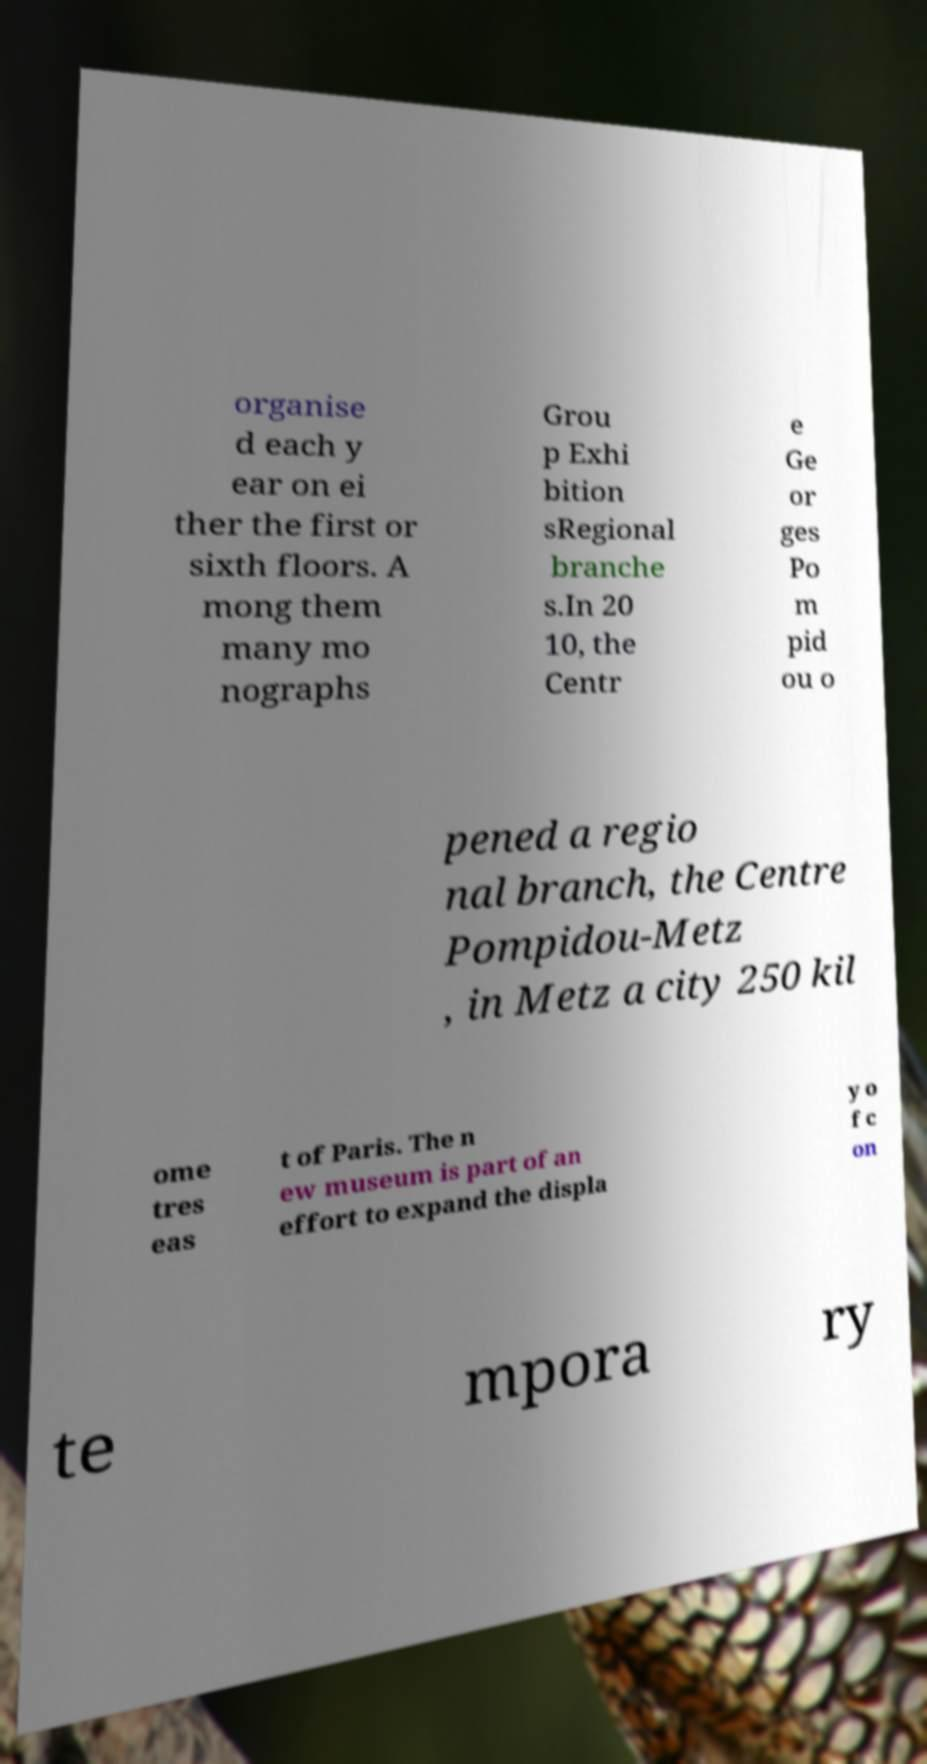I need the written content from this picture converted into text. Can you do that? organise d each y ear on ei ther the first or sixth floors. A mong them many mo nographs Grou p Exhi bition sRegional branche s.In 20 10, the Centr e Ge or ges Po m pid ou o pened a regio nal branch, the Centre Pompidou-Metz , in Metz a city 250 kil ome tres eas t of Paris. The n ew museum is part of an effort to expand the displa y o f c on te mpora ry 